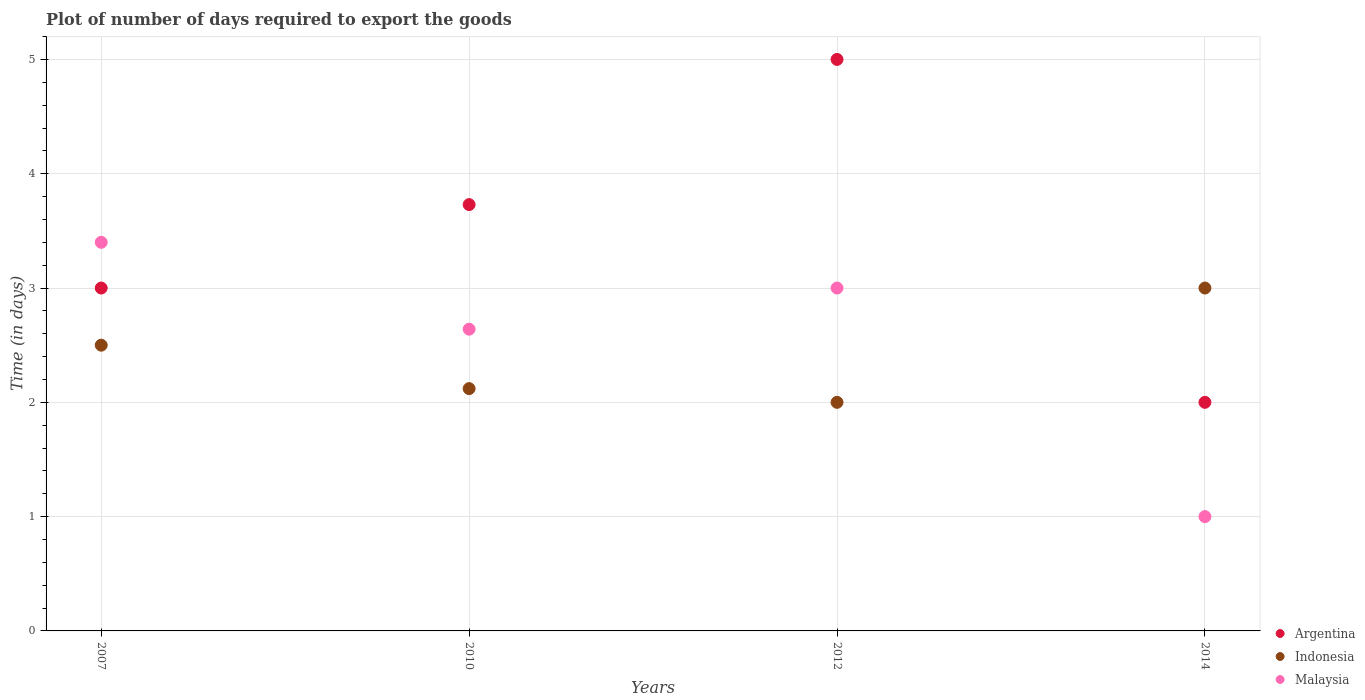Is the number of dotlines equal to the number of legend labels?
Offer a terse response. Yes. What is the time required to export goods in Indonesia in 2010?
Provide a succinct answer. 2.12. Across all years, what is the minimum time required to export goods in Indonesia?
Provide a short and direct response. 2. In which year was the time required to export goods in Indonesia minimum?
Your response must be concise. 2012. What is the total time required to export goods in Argentina in the graph?
Provide a short and direct response. 13.73. What is the difference between the time required to export goods in Indonesia in 2010 and that in 2012?
Give a very brief answer. 0.12. What is the difference between the time required to export goods in Argentina in 2012 and the time required to export goods in Malaysia in 2010?
Provide a short and direct response. 2.36. What is the average time required to export goods in Malaysia per year?
Your answer should be compact. 2.51. In the year 2014, what is the difference between the time required to export goods in Argentina and time required to export goods in Malaysia?
Your response must be concise. 1. In how many years, is the time required to export goods in Malaysia greater than 2.2 days?
Make the answer very short. 3. What is the ratio of the time required to export goods in Indonesia in 2010 to that in 2012?
Give a very brief answer. 1.06. What is the difference between the highest and the second highest time required to export goods in Indonesia?
Provide a short and direct response. 0.5. What is the difference between the highest and the lowest time required to export goods in Argentina?
Ensure brevity in your answer.  3. In how many years, is the time required to export goods in Argentina greater than the average time required to export goods in Argentina taken over all years?
Provide a succinct answer. 2. Is the sum of the time required to export goods in Indonesia in 2007 and 2010 greater than the maximum time required to export goods in Malaysia across all years?
Offer a very short reply. Yes. Is it the case that in every year, the sum of the time required to export goods in Malaysia and time required to export goods in Argentina  is greater than the time required to export goods in Indonesia?
Make the answer very short. No. Does the time required to export goods in Indonesia monotonically increase over the years?
Your answer should be compact. No. Is the time required to export goods in Malaysia strictly less than the time required to export goods in Indonesia over the years?
Ensure brevity in your answer.  No. How many dotlines are there?
Your answer should be very brief. 3. How many years are there in the graph?
Provide a succinct answer. 4. What is the difference between two consecutive major ticks on the Y-axis?
Offer a terse response. 1. Are the values on the major ticks of Y-axis written in scientific E-notation?
Your response must be concise. No. Does the graph contain grids?
Ensure brevity in your answer.  Yes. Where does the legend appear in the graph?
Keep it short and to the point. Bottom right. How many legend labels are there?
Provide a succinct answer. 3. How are the legend labels stacked?
Offer a very short reply. Vertical. What is the title of the graph?
Make the answer very short. Plot of number of days required to export the goods. Does "Liechtenstein" appear as one of the legend labels in the graph?
Provide a succinct answer. No. What is the label or title of the X-axis?
Give a very brief answer. Years. What is the label or title of the Y-axis?
Provide a short and direct response. Time (in days). What is the Time (in days) of Argentina in 2007?
Offer a very short reply. 3. What is the Time (in days) in Indonesia in 2007?
Your answer should be compact. 2.5. What is the Time (in days) in Malaysia in 2007?
Your answer should be compact. 3.4. What is the Time (in days) of Argentina in 2010?
Provide a succinct answer. 3.73. What is the Time (in days) in Indonesia in 2010?
Offer a terse response. 2.12. What is the Time (in days) of Malaysia in 2010?
Your response must be concise. 2.64. What is the Time (in days) in Indonesia in 2012?
Provide a short and direct response. 2. What is the Time (in days) in Malaysia in 2012?
Offer a terse response. 3. What is the Time (in days) in Argentina in 2014?
Your answer should be very brief. 2. What is the Time (in days) in Indonesia in 2014?
Ensure brevity in your answer.  3. Across all years, what is the maximum Time (in days) of Indonesia?
Offer a terse response. 3. Across all years, what is the minimum Time (in days) of Argentina?
Give a very brief answer. 2. What is the total Time (in days) in Argentina in the graph?
Your answer should be very brief. 13.73. What is the total Time (in days) of Indonesia in the graph?
Your answer should be very brief. 9.62. What is the total Time (in days) of Malaysia in the graph?
Offer a terse response. 10.04. What is the difference between the Time (in days) of Argentina in 2007 and that in 2010?
Provide a succinct answer. -0.73. What is the difference between the Time (in days) in Indonesia in 2007 and that in 2010?
Offer a very short reply. 0.38. What is the difference between the Time (in days) of Malaysia in 2007 and that in 2010?
Offer a terse response. 0.76. What is the difference between the Time (in days) in Argentina in 2007 and that in 2012?
Give a very brief answer. -2. What is the difference between the Time (in days) of Indonesia in 2007 and that in 2012?
Your answer should be very brief. 0.5. What is the difference between the Time (in days) in Malaysia in 2007 and that in 2014?
Your response must be concise. 2.4. What is the difference between the Time (in days) in Argentina in 2010 and that in 2012?
Make the answer very short. -1.27. What is the difference between the Time (in days) of Indonesia in 2010 and that in 2012?
Give a very brief answer. 0.12. What is the difference between the Time (in days) of Malaysia in 2010 and that in 2012?
Offer a very short reply. -0.36. What is the difference between the Time (in days) in Argentina in 2010 and that in 2014?
Make the answer very short. 1.73. What is the difference between the Time (in days) of Indonesia in 2010 and that in 2014?
Your answer should be very brief. -0.88. What is the difference between the Time (in days) of Malaysia in 2010 and that in 2014?
Your response must be concise. 1.64. What is the difference between the Time (in days) in Argentina in 2012 and that in 2014?
Keep it short and to the point. 3. What is the difference between the Time (in days) of Indonesia in 2012 and that in 2014?
Ensure brevity in your answer.  -1. What is the difference between the Time (in days) of Malaysia in 2012 and that in 2014?
Your answer should be compact. 2. What is the difference between the Time (in days) of Argentina in 2007 and the Time (in days) of Malaysia in 2010?
Provide a short and direct response. 0.36. What is the difference between the Time (in days) in Indonesia in 2007 and the Time (in days) in Malaysia in 2010?
Ensure brevity in your answer.  -0.14. What is the difference between the Time (in days) of Argentina in 2007 and the Time (in days) of Malaysia in 2012?
Offer a very short reply. 0. What is the difference between the Time (in days) in Indonesia in 2007 and the Time (in days) in Malaysia in 2012?
Keep it short and to the point. -0.5. What is the difference between the Time (in days) in Argentina in 2007 and the Time (in days) in Malaysia in 2014?
Your answer should be very brief. 2. What is the difference between the Time (in days) of Argentina in 2010 and the Time (in days) of Indonesia in 2012?
Offer a very short reply. 1.73. What is the difference between the Time (in days) in Argentina in 2010 and the Time (in days) in Malaysia in 2012?
Keep it short and to the point. 0.73. What is the difference between the Time (in days) of Indonesia in 2010 and the Time (in days) of Malaysia in 2012?
Ensure brevity in your answer.  -0.88. What is the difference between the Time (in days) in Argentina in 2010 and the Time (in days) in Indonesia in 2014?
Your answer should be very brief. 0.73. What is the difference between the Time (in days) in Argentina in 2010 and the Time (in days) in Malaysia in 2014?
Your answer should be very brief. 2.73. What is the difference between the Time (in days) in Indonesia in 2010 and the Time (in days) in Malaysia in 2014?
Offer a very short reply. 1.12. What is the difference between the Time (in days) in Argentina in 2012 and the Time (in days) in Malaysia in 2014?
Ensure brevity in your answer.  4. What is the average Time (in days) in Argentina per year?
Make the answer very short. 3.43. What is the average Time (in days) of Indonesia per year?
Offer a very short reply. 2.4. What is the average Time (in days) in Malaysia per year?
Your answer should be very brief. 2.51. In the year 2007, what is the difference between the Time (in days) of Argentina and Time (in days) of Malaysia?
Your answer should be compact. -0.4. In the year 2007, what is the difference between the Time (in days) of Indonesia and Time (in days) of Malaysia?
Your answer should be very brief. -0.9. In the year 2010, what is the difference between the Time (in days) in Argentina and Time (in days) in Indonesia?
Offer a very short reply. 1.61. In the year 2010, what is the difference between the Time (in days) of Argentina and Time (in days) of Malaysia?
Provide a short and direct response. 1.09. In the year 2010, what is the difference between the Time (in days) in Indonesia and Time (in days) in Malaysia?
Give a very brief answer. -0.52. In the year 2012, what is the difference between the Time (in days) in Argentina and Time (in days) in Malaysia?
Ensure brevity in your answer.  2. In the year 2014, what is the difference between the Time (in days) of Argentina and Time (in days) of Indonesia?
Offer a very short reply. -1. What is the ratio of the Time (in days) in Argentina in 2007 to that in 2010?
Your answer should be compact. 0.8. What is the ratio of the Time (in days) in Indonesia in 2007 to that in 2010?
Keep it short and to the point. 1.18. What is the ratio of the Time (in days) of Malaysia in 2007 to that in 2010?
Make the answer very short. 1.29. What is the ratio of the Time (in days) of Malaysia in 2007 to that in 2012?
Your answer should be compact. 1.13. What is the ratio of the Time (in days) in Malaysia in 2007 to that in 2014?
Offer a very short reply. 3.4. What is the ratio of the Time (in days) in Argentina in 2010 to that in 2012?
Your answer should be compact. 0.75. What is the ratio of the Time (in days) in Indonesia in 2010 to that in 2012?
Offer a very short reply. 1.06. What is the ratio of the Time (in days) in Argentina in 2010 to that in 2014?
Offer a terse response. 1.86. What is the ratio of the Time (in days) in Indonesia in 2010 to that in 2014?
Ensure brevity in your answer.  0.71. What is the ratio of the Time (in days) in Malaysia in 2010 to that in 2014?
Your response must be concise. 2.64. What is the ratio of the Time (in days) of Argentina in 2012 to that in 2014?
Offer a very short reply. 2.5. What is the difference between the highest and the second highest Time (in days) of Argentina?
Your answer should be compact. 1.27. What is the difference between the highest and the lowest Time (in days) in Indonesia?
Offer a very short reply. 1. What is the difference between the highest and the lowest Time (in days) of Malaysia?
Make the answer very short. 2.4. 